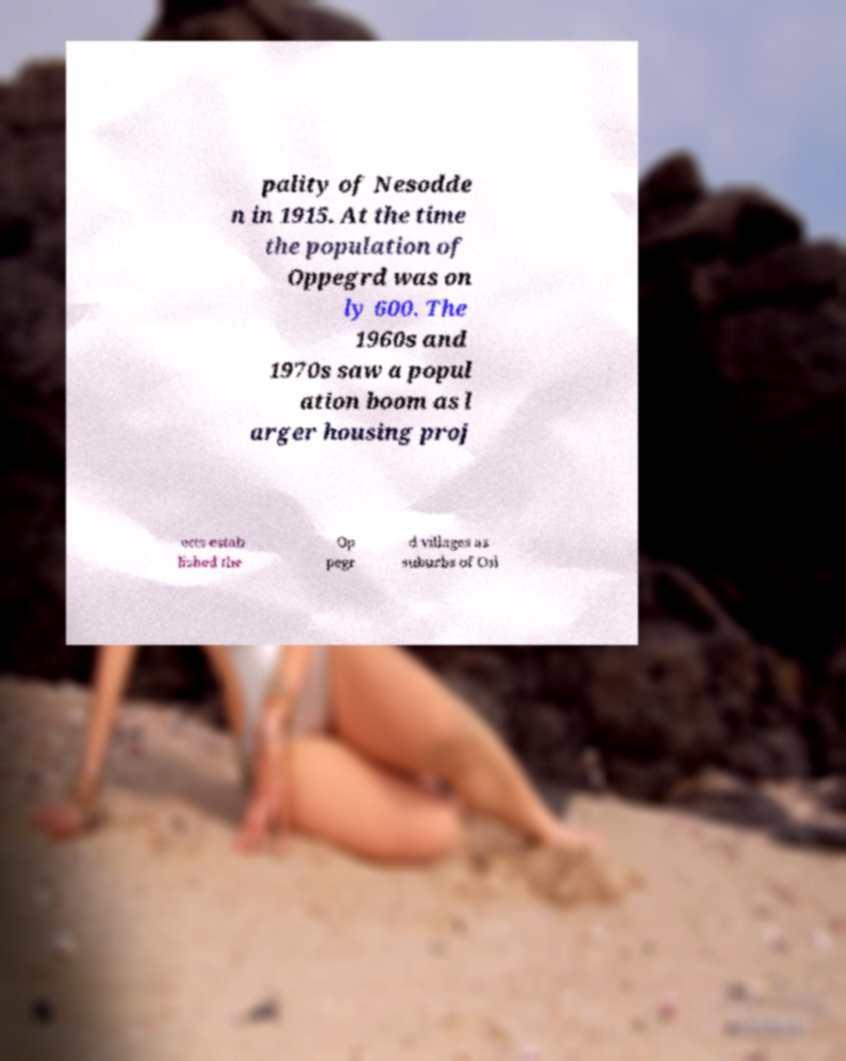Could you extract and type out the text from this image? pality of Nesodde n in 1915. At the time the population of Oppegrd was on ly 600. The 1960s and 1970s saw a popul ation boom as l arger housing proj ects estab lished the Op pegr d villages as suburbs of Osl 